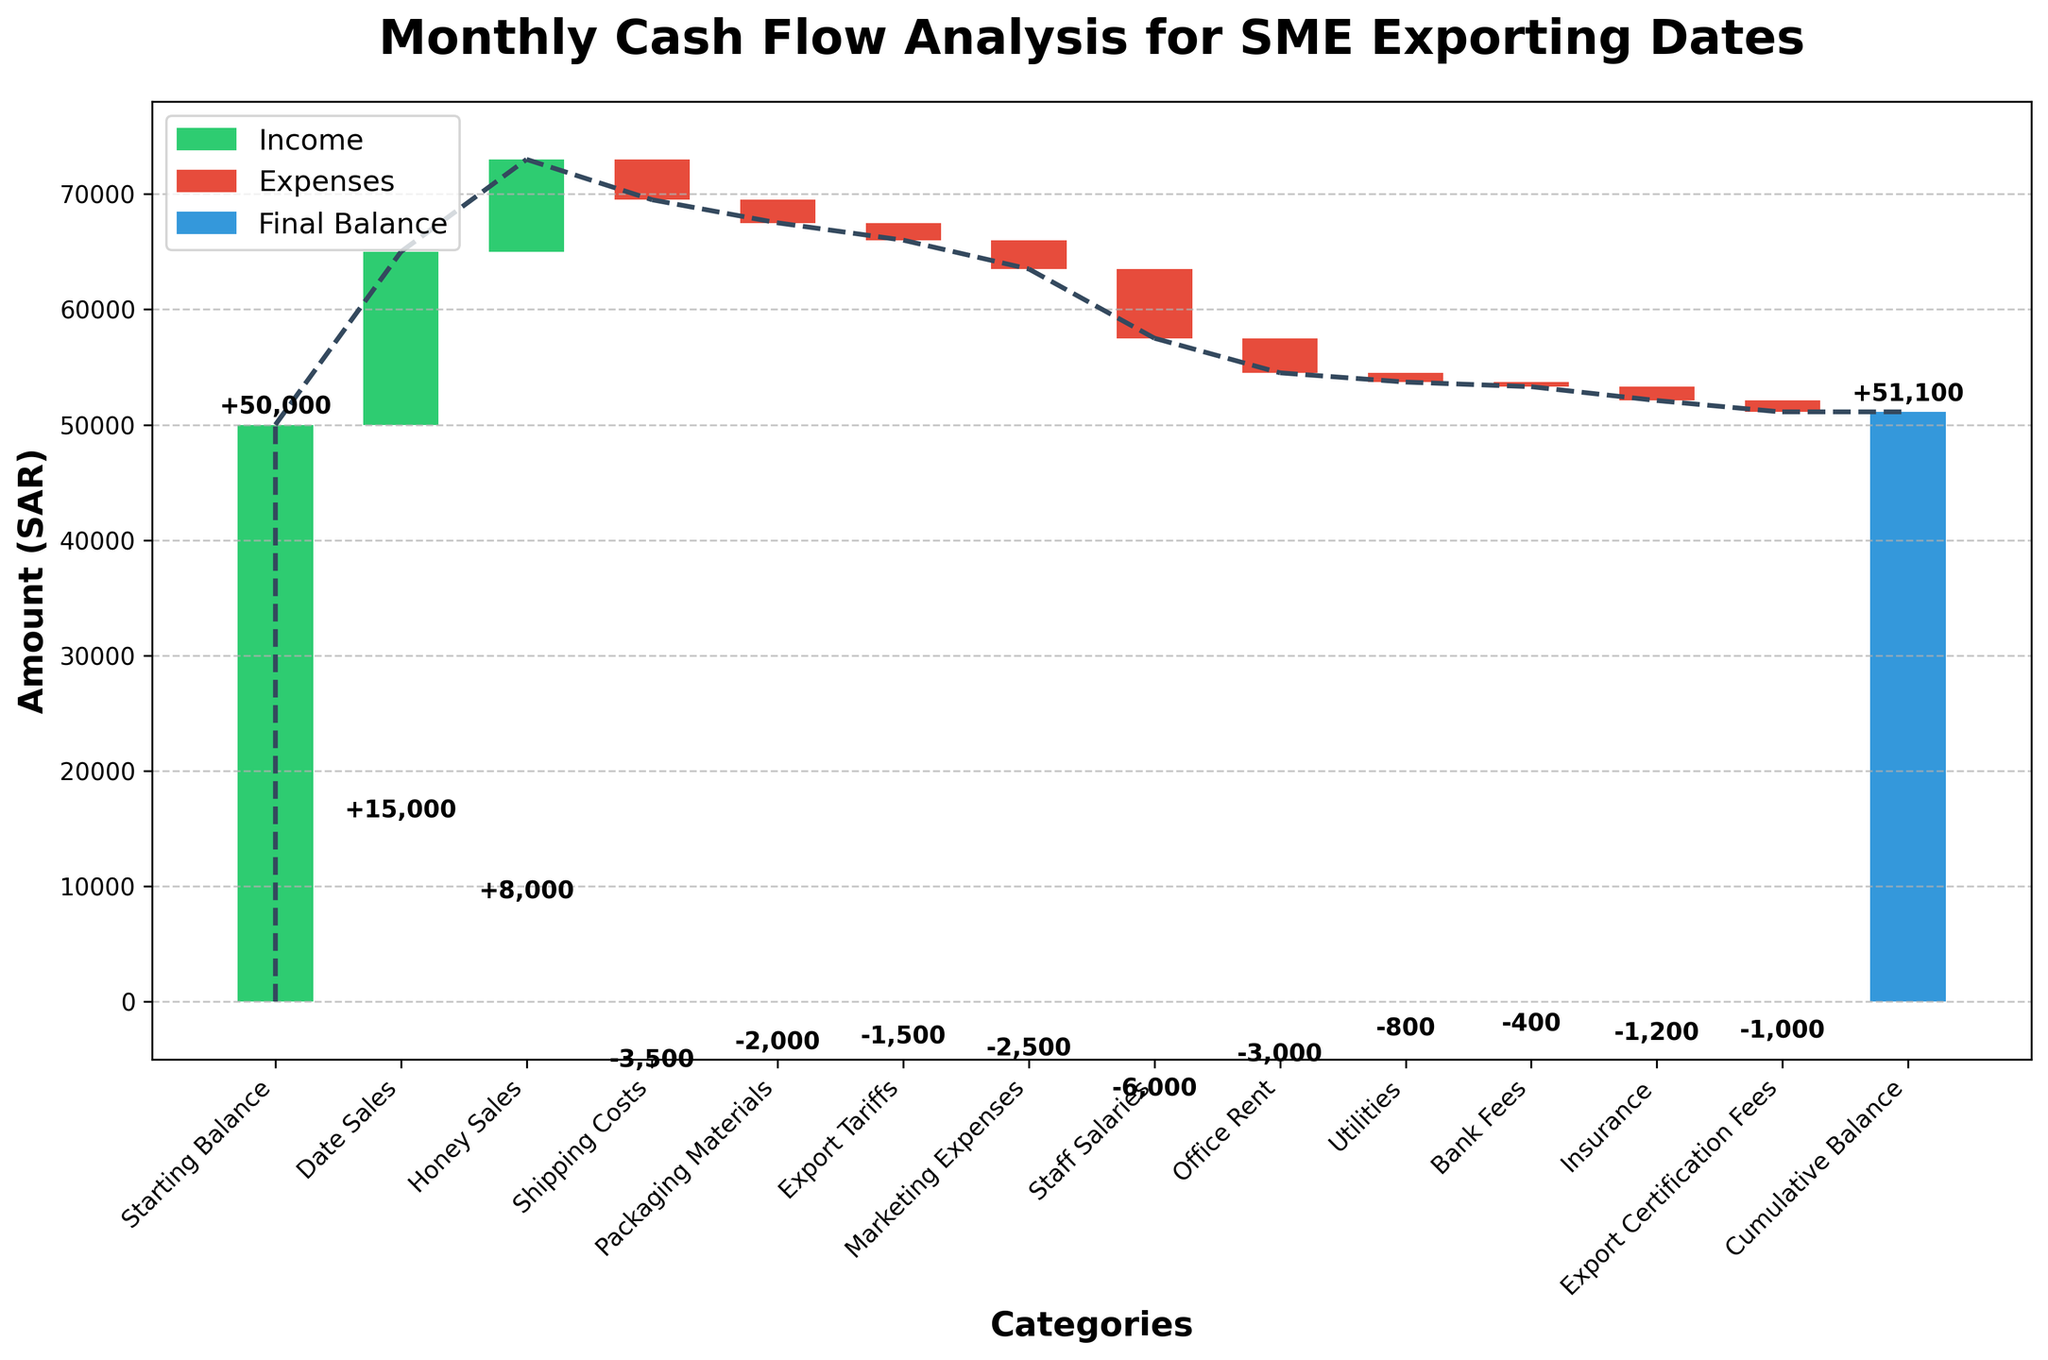What is the title of the chart? The title is usually located at the top of the chart and is used to describe what the chart is about.
Answer: Monthly Cash Flow Analysis for SME Exporting Dates What is the initial starting balance? The initial starting balance is the first bar in the waterfall chart, representing the starting point before any income or expenses are added.
Answer: 50,000 SAR How much did the company earn from Date Sales and Honey Sales combined? To find the combined earnings from Date Sales and Honey Sales, you add both amounts together. Date Sales are 15,000 SAR and Honey Sales are 8,000 SAR. 15,000 + 8,000 = 23,000 SAR.
Answer: 23,000 SAR Which expense had the highest impact (greatest amount) on the cash flow? The highest impact on cash flow would be the largest negative value among the expenses. Examining the chart, Staff Salaries is -6000 SAR, which is the most significant expense.
Answer: Staff Salaries How does the Cumulative Balance at the end compare with the Starting Balance? To compare the cumulative balance with the starting balance, look at the last bar representing the cumulative balance and the first bar for the starting balance. The cumulative balance is 51,100 SAR, which is 1,100 SAR higher than the starting balance of 50,000 SAR.
Answer: 1,100 SAR higher What are the total expenses incurred by the company? Add all the negative values representing expenses: -3,500 (Shipping Costs) + -2,000 (Packaging Materials) + -1,500 (Export Tariffs) + -2,500 (Marketing Expenses) + -6,000 (Staff Salaries) + -3,000 (Office Rent) + -800 (Utilities) + -400 (Bank Fees) + -1,200 (Insurance) + -1,000 (Export Certification Fees) = -22,900 SAR.
Answer: 22,900 SAR Which income category contributed less to the cash flow: Date Sales or Honey Sales? Compare the values of Date Sales and Honey Sales. Date Sales are 15,000 SAR, and Honey Sales are 8,000 SAR. The smaller value is Honey Sales.
Answer: Honey Sales What is the cumulative balance after deducting all expenses but before adding incomes? Start from the starting balance, subtract all expenses: 50,000 SAR - (3,500 + 2,000 + 1,500 + 2,500 + 6,000 + 3,000 + 800 + 400 + 1,200 + 1,000) = 50,000 SAR - 22,900 SAR = 27,100 SAR, then add incomes = 27,100 + (15,000 + 8,000) = 50,100 SAR. The cumulative balance would be 50,100 SAR as shown before moving to final calculation.
Answer: 27,100 SAR 